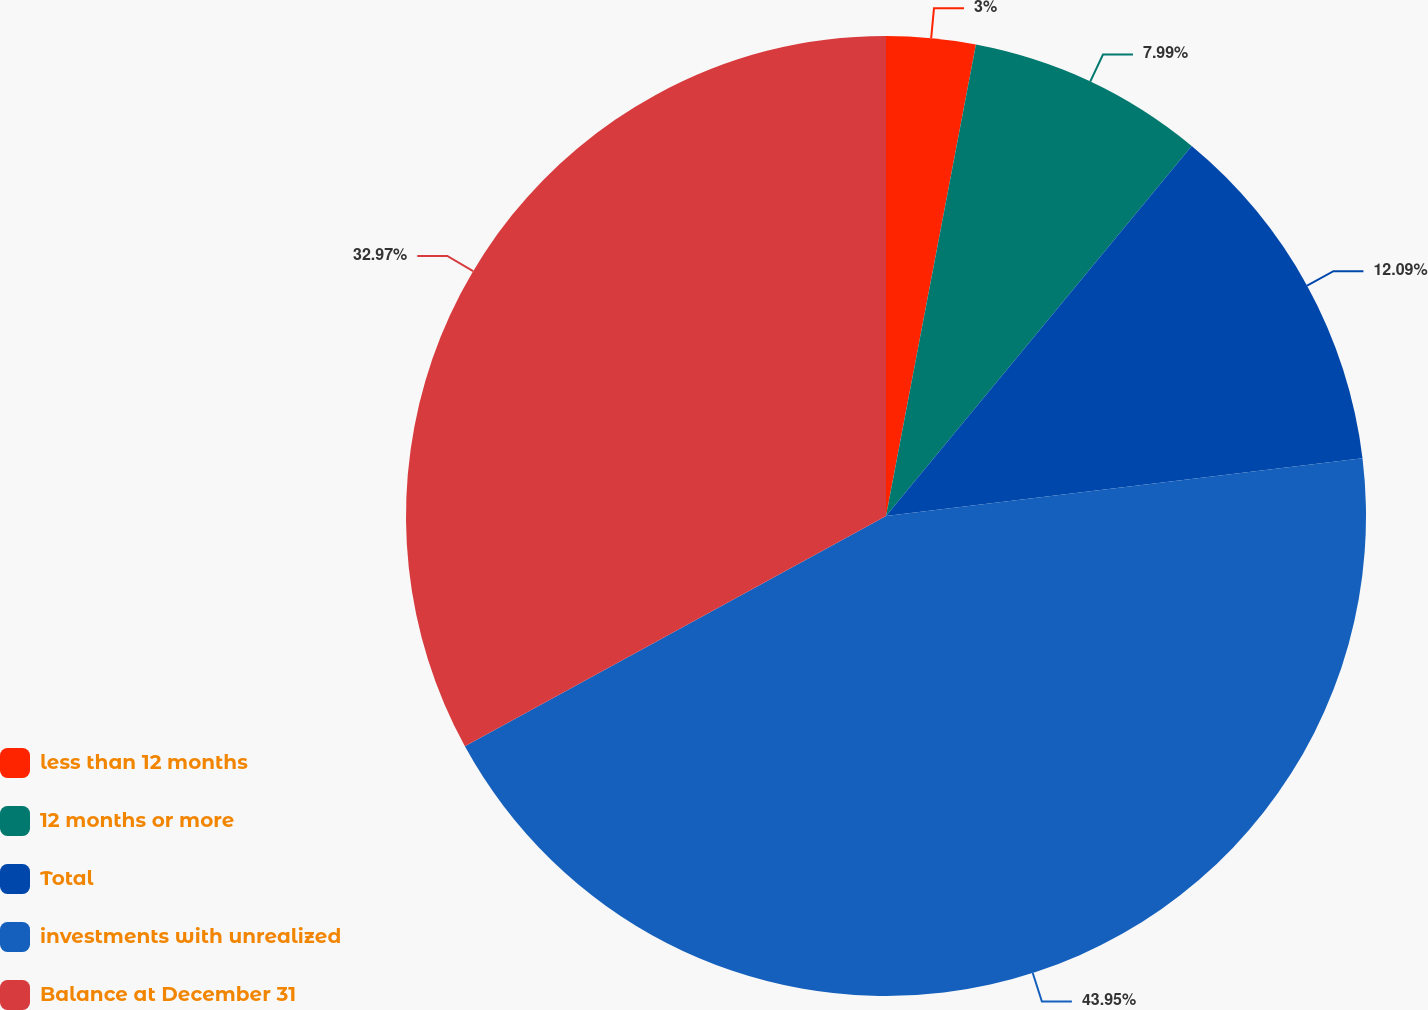Convert chart. <chart><loc_0><loc_0><loc_500><loc_500><pie_chart><fcel>less than 12 months<fcel>12 months or more<fcel>Total<fcel>investments with unrealized<fcel>Balance at December 31<nl><fcel>3.0%<fcel>7.99%<fcel>12.09%<fcel>43.96%<fcel>32.97%<nl></chart> 